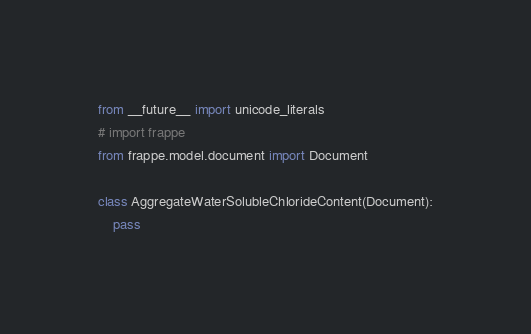<code> <loc_0><loc_0><loc_500><loc_500><_Python_>from __future__ import unicode_literals
# import frappe
from frappe.model.document import Document

class AggregateWaterSolubleChlorideContent(Document):
	pass
</code> 